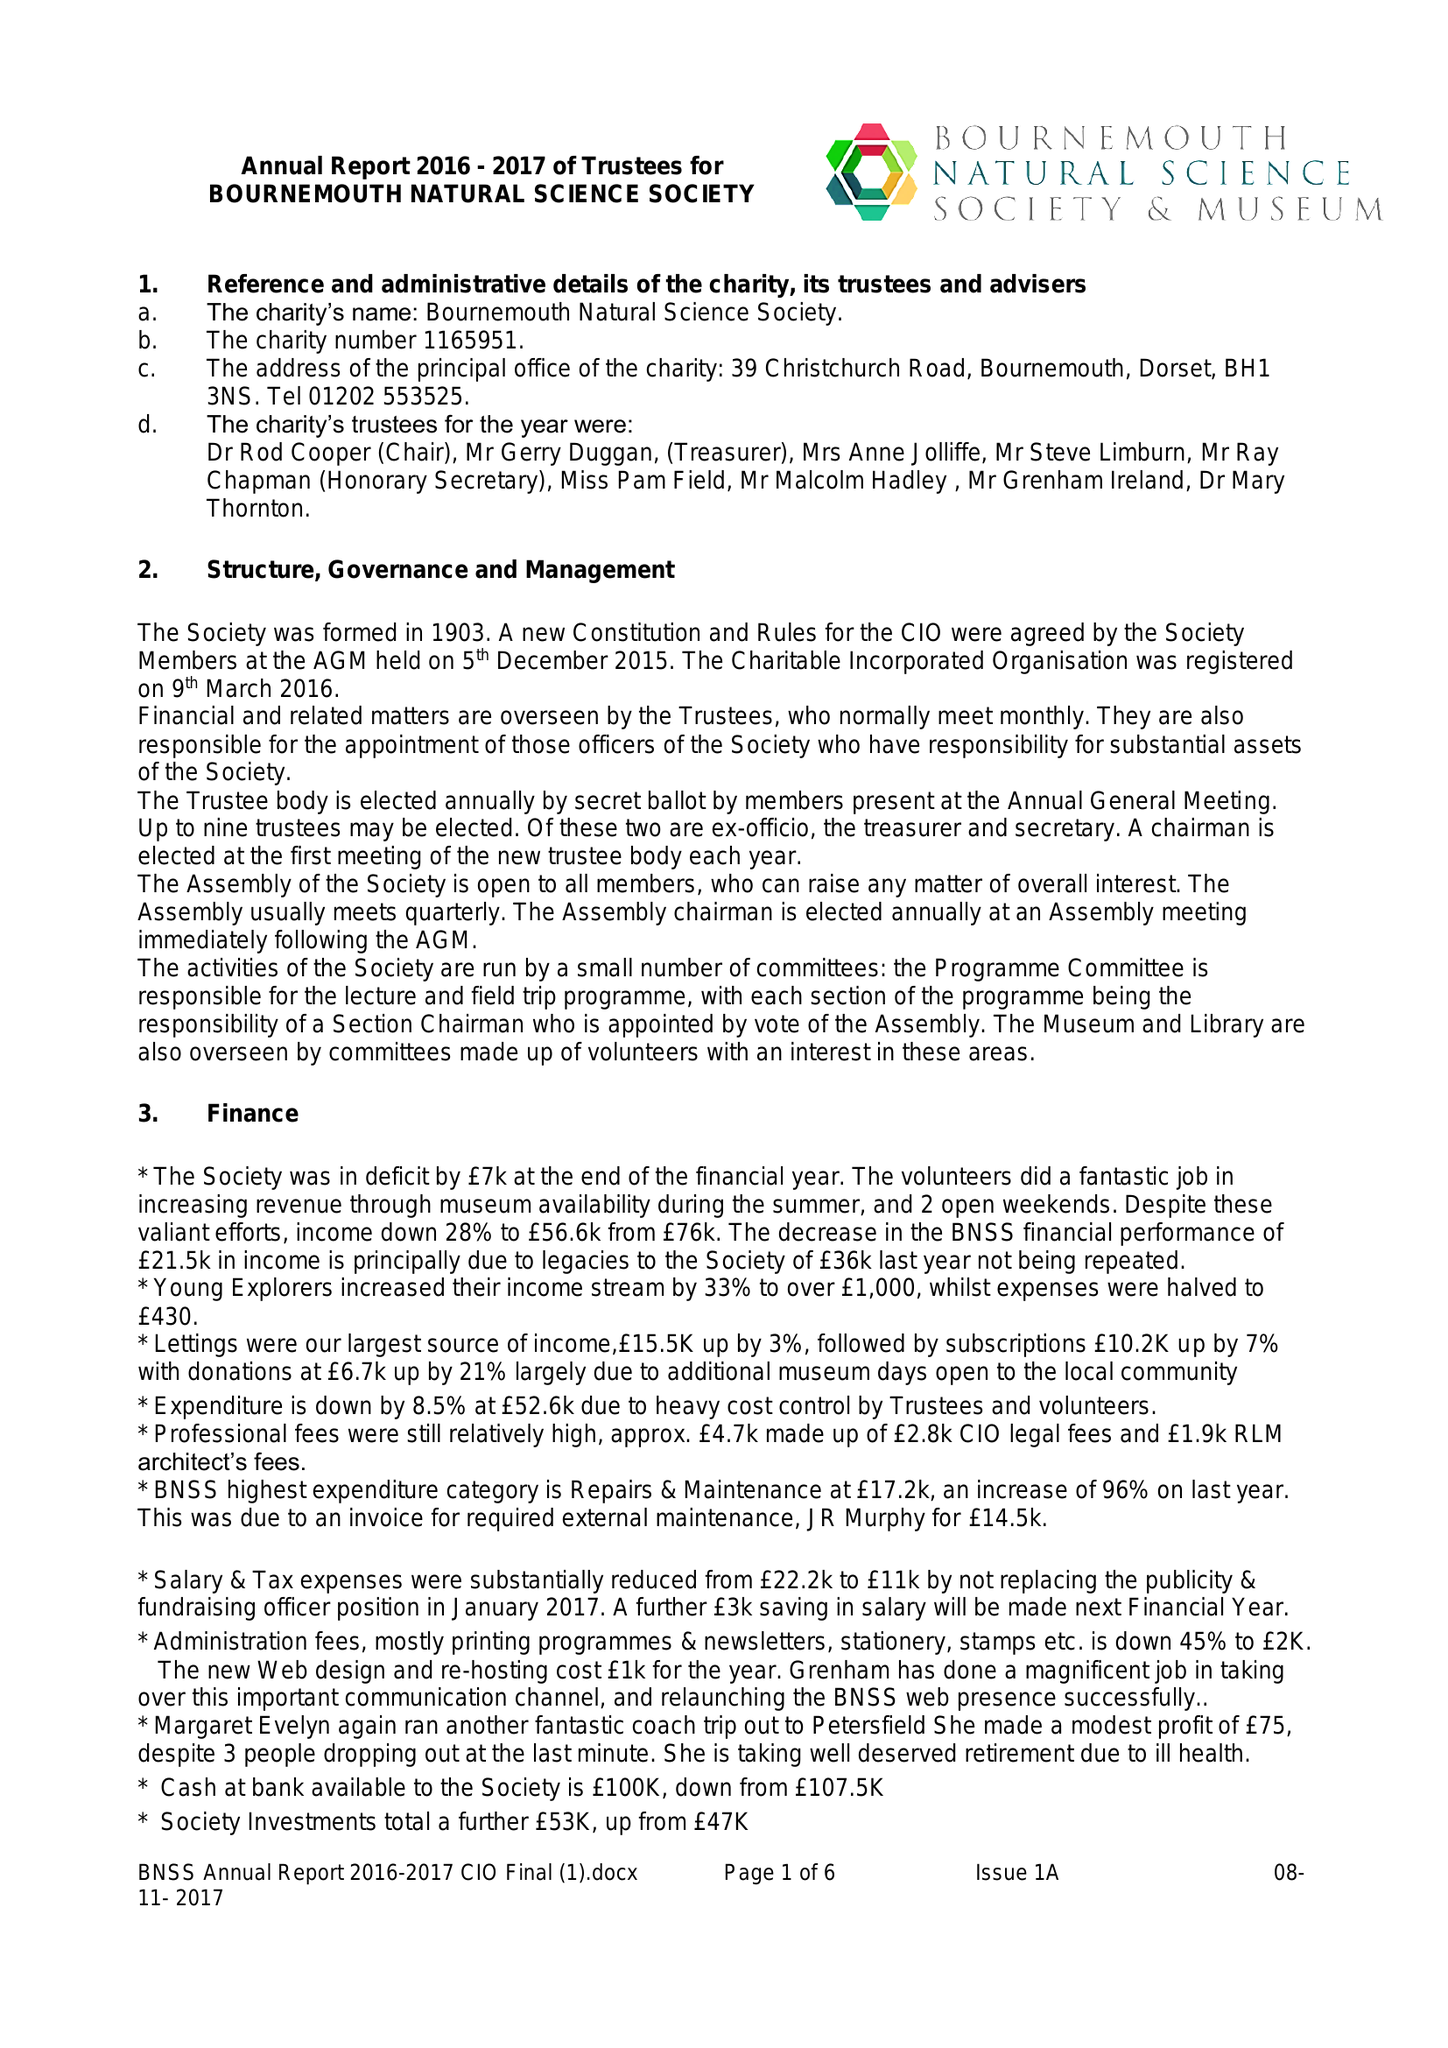What is the value for the address__post_town?
Answer the question using a single word or phrase. BOURNEMOUTH 